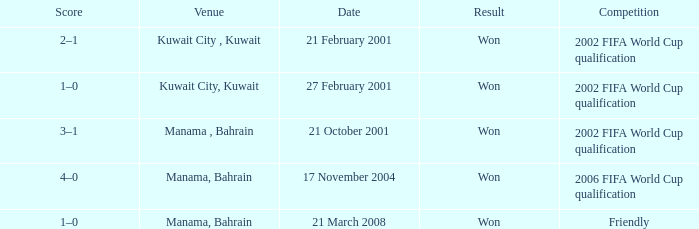On which date was the match in Manama, Bahrain? 21 October 2001, 17 November 2004, 21 March 2008. 